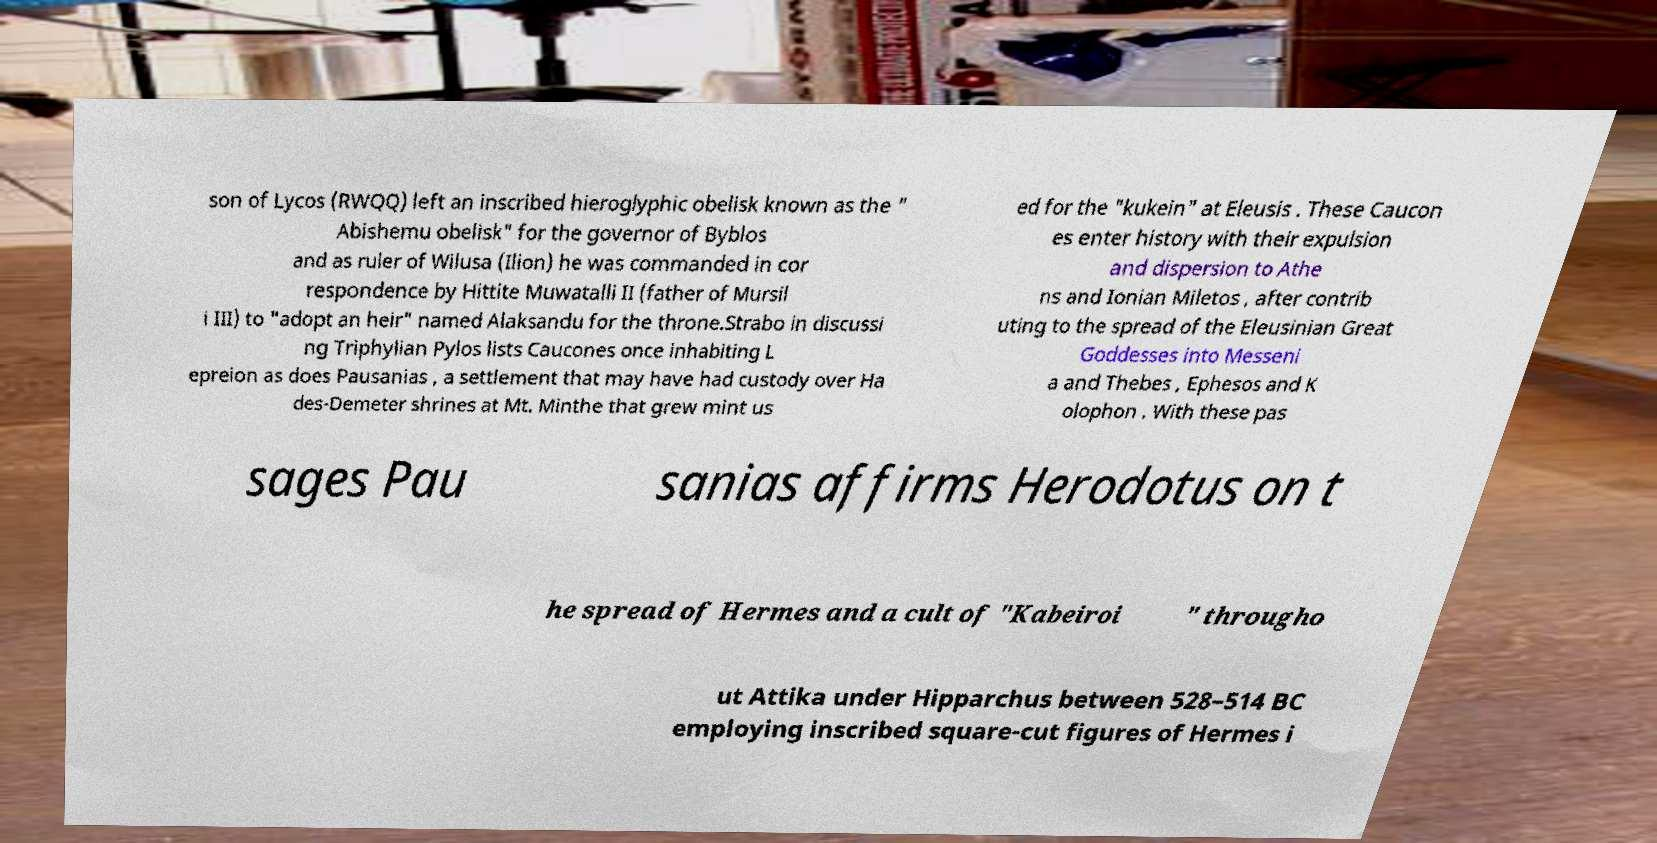Could you extract and type out the text from this image? son of Lycos (RWQQ) left an inscribed hieroglyphic obelisk known as the " Abishemu obelisk" for the governor of Byblos and as ruler of Wilusa (Ilion) he was commanded in cor respondence by Hittite Muwatalli II (father of Mursil i III) to "adopt an heir" named Alaksandu for the throne.Strabo in discussi ng Triphylian Pylos lists Caucones once inhabiting L epreion as does Pausanias , a settlement that may have had custody over Ha des-Demeter shrines at Mt. Minthe that grew mint us ed for the "kukein" at Eleusis . These Caucon es enter history with their expulsion and dispersion to Athe ns and Ionian Miletos , after contrib uting to the spread of the Eleusinian Great Goddesses into Messeni a and Thebes , Ephesos and K olophon . With these pas sages Pau sanias affirms Herodotus on t he spread of Hermes and a cult of "Kabeiroi " througho ut Attika under Hipparchus between 528–514 BC employing inscribed square-cut figures of Hermes i 